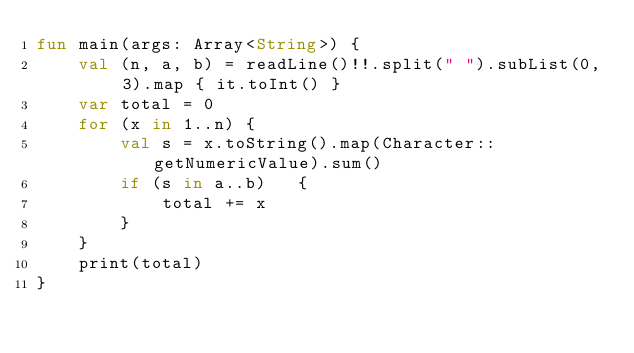<code> <loc_0><loc_0><loc_500><loc_500><_Kotlin_>fun main(args: Array<String>) {
    val (n, a, b) = readLine()!!.split(" ").subList(0, 3).map { it.toInt() }
    var total = 0
    for (x in 1..n) {
        val s = x.toString().map(Character::getNumericValue).sum()
        if (s in a..b)   {
            total += x
        }
    }
    print(total)
}
</code> 